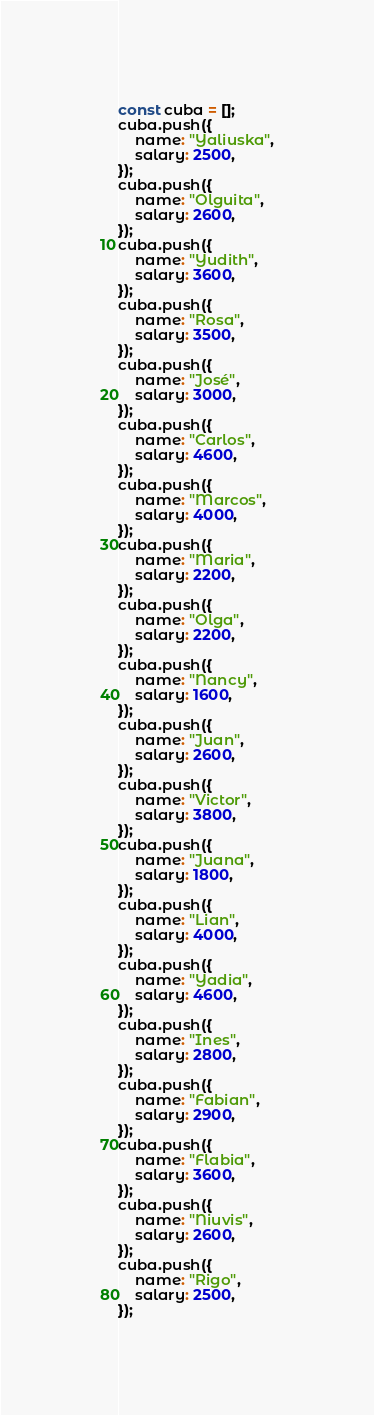Convert code to text. <code><loc_0><loc_0><loc_500><loc_500><_JavaScript_>const cuba = [];
cuba.push({
    name: "Yaliuska",
    salary: 2500,
});
cuba.push({
    name: "Olguita",
    salary: 2600,
});
cuba.push({
    name: "Yudith",
    salary: 3600,
});
cuba.push({
    name: "Rosa",
    salary: 3500,
});
cuba.push({
    name: "José",
    salary: 3000,
});
cuba.push({
    name: "Carlos",
    salary: 4600,
});
cuba.push({
    name: "Marcos",
    salary: 4000,
});
cuba.push({
    name: "Maria",
    salary: 2200,
});
cuba.push({
    name: "Olga",
    salary: 2200,
});
cuba.push({
    name: "Nancy",
    salary: 1600,
});
cuba.push({
    name: "Juan",
    salary: 2600,
});
cuba.push({
    name: "Victor",
    salary: 3800,
});
cuba.push({
    name: "Juana",
    salary: 1800,
});
cuba.push({
    name: "Lian",
    salary: 4000,
});
cuba.push({
    name: "Yadia",
    salary: 4600,
});
cuba.push({
    name: "Ines",
    salary: 2800,
});
cuba.push({
    name: "Fabian",
    salary: 2900,
});
cuba.push({
    name: "Flabia",
    salary: 3600,
});
cuba.push({
    name: "Niuvis",
    salary: 2600,
});
cuba.push({
    name: "Rigo",
    salary: 2500,
});
</code> 